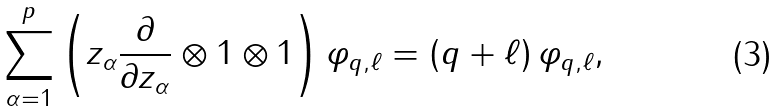<formula> <loc_0><loc_0><loc_500><loc_500>\sum _ { \alpha = 1 } ^ { p } \left ( z _ { \alpha } \frac { \partial } { \partial z _ { \alpha } } \otimes 1 \otimes 1 \right ) \varphi _ { q , \ell } = ( q + \ell ) \, \varphi _ { q , \ell } ,</formula> 